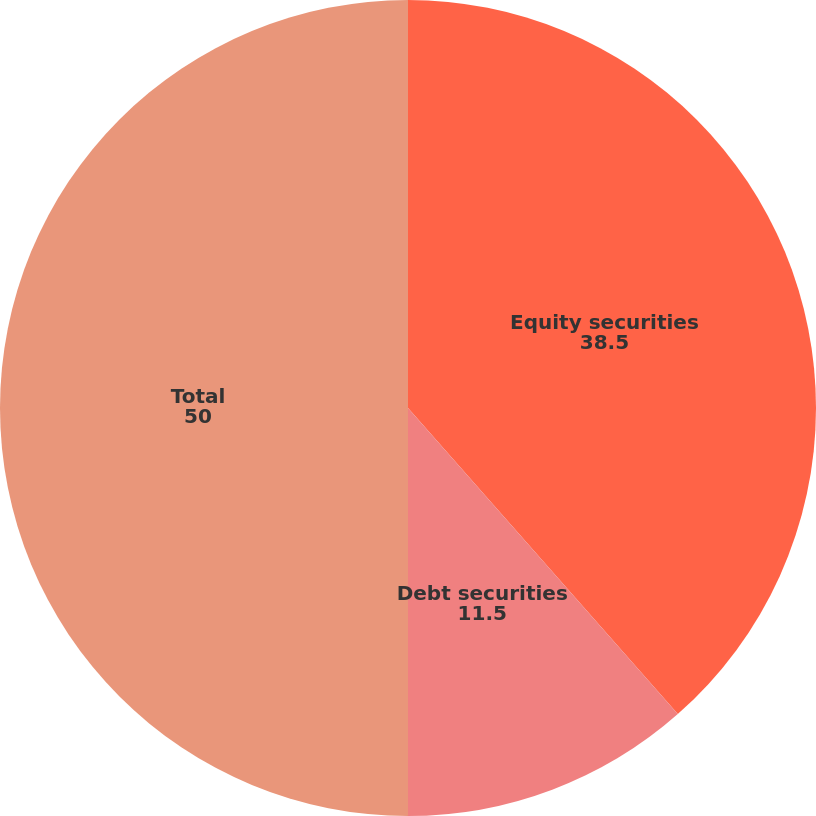Convert chart. <chart><loc_0><loc_0><loc_500><loc_500><pie_chart><fcel>Equity securities<fcel>Debt securities<fcel>Total<nl><fcel>38.5%<fcel>11.5%<fcel>50.0%<nl></chart> 